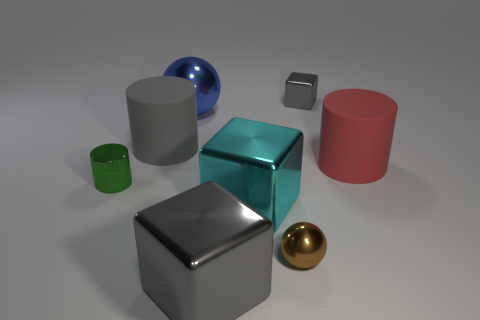What number of gray things are either small spheres or cylinders?
Offer a very short reply. 1. What is the material of the gray object that is the same size as the green shiny cylinder?
Provide a short and direct response. Metal. The gray object that is both on the right side of the blue sphere and behind the tiny brown metal ball has what shape?
Keep it short and to the point. Cube. The metallic cylinder that is the same size as the brown thing is what color?
Give a very brief answer. Green. Do the cylinder that is on the right side of the gray rubber cylinder and the metal cube that is behind the red matte cylinder have the same size?
Keep it short and to the point. No. How big is the matte cylinder to the left of the block behind the big metal block that is to the right of the big gray metallic object?
Your response must be concise. Large. The gray metal object that is behind the big rubber object that is to the left of the red cylinder is what shape?
Your answer should be very brief. Cube. There is a metallic ball in front of the cyan metallic object; is it the same color as the big ball?
Ensure brevity in your answer.  No. The thing that is to the right of the small metal ball and to the left of the red thing is what color?
Ensure brevity in your answer.  Gray. Are there any large cyan things made of the same material as the big red thing?
Your response must be concise. No. 